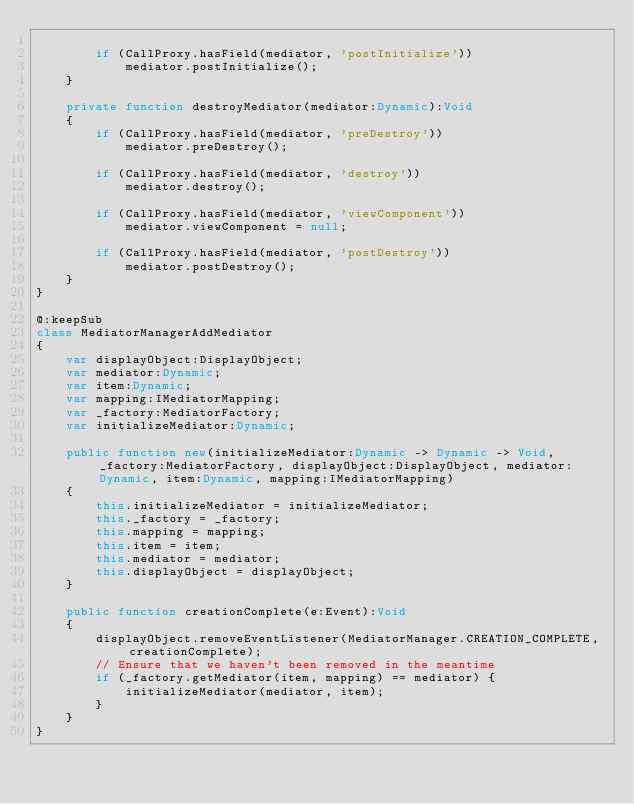Convert code to text. <code><loc_0><loc_0><loc_500><loc_500><_Haxe_>
		if (CallProxy.hasField(mediator, 'postInitialize'))
			mediator.postInitialize();
	}

	private function destroyMediator(mediator:Dynamic):Void
	{
		if (CallProxy.hasField(mediator, 'preDestroy'))
			mediator.preDestroy();

		if (CallProxy.hasField(mediator, 'destroy'))
			mediator.destroy();

		if (CallProxy.hasField(mediator, 'viewComponent'))
			mediator.viewComponent = null;

		if (CallProxy.hasField(mediator, 'postDestroy'))
			mediator.postDestroy();
	}
}

@:keepSub
class MediatorManagerAddMediator
{
	var displayObject:DisplayObject;
	var mediator:Dynamic;
	var item:Dynamic;
	var mapping:IMediatorMapping;
	var _factory:MediatorFactory;
	var initializeMediator:Dynamic;
	
	public function new(initializeMediator:Dynamic -> Dynamic -> Void, _factory:MediatorFactory, displayObject:DisplayObject, mediator:Dynamic, item:Dynamic, mapping:IMediatorMapping)
	{
		this.initializeMediator = initializeMediator;
		this._factory = _factory;
		this.mapping = mapping;
		this.item = item;
		this.mediator = mediator;
		this.displayObject = displayObject;
	}
	
	public function creationComplete(e:Event):Void 
	{
		displayObject.removeEventListener(MediatorManager.CREATION_COMPLETE, creationComplete);
		// Ensure that we haven't been removed in the meantime
		if (_factory.getMediator(item, mapping) == mediator) {
			initializeMediator(mediator, item);
		}
	}
}</code> 